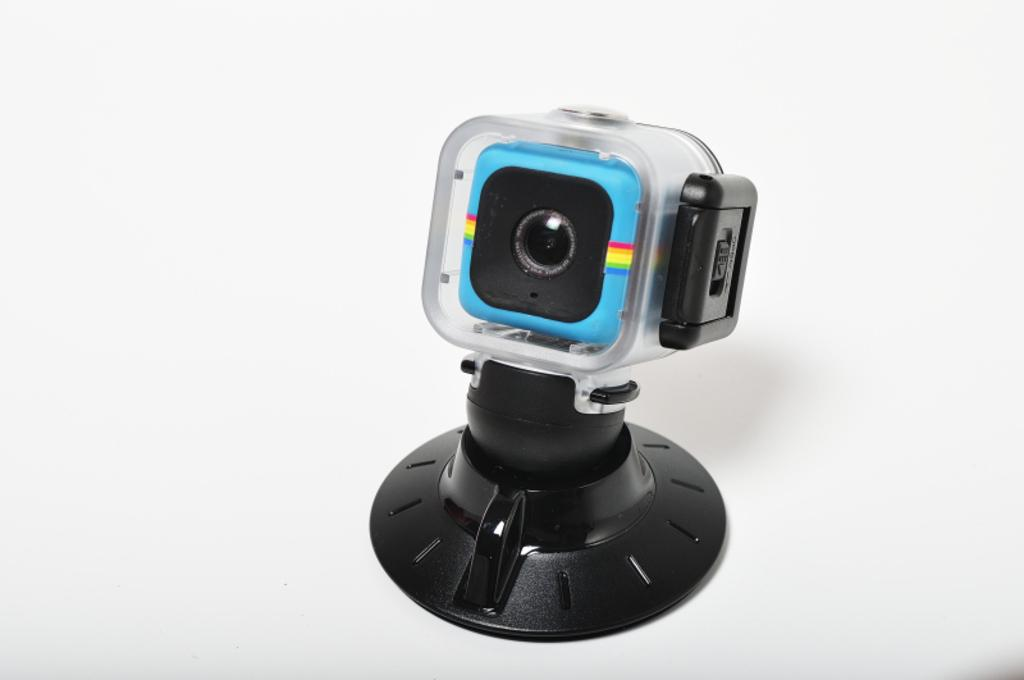What is the main object in the image? There is a camera in the image. What is the camera supported by? The camera has a stand. Where is the camera and stand located? The camera and stand are on a table. What type of group activity is taking place in the image? There is no group activity present in the image; it features a camera and stand on a table. Can you see a chessboard or chess pieces in the image? There is no chessboard or chess pieces present in the image. 